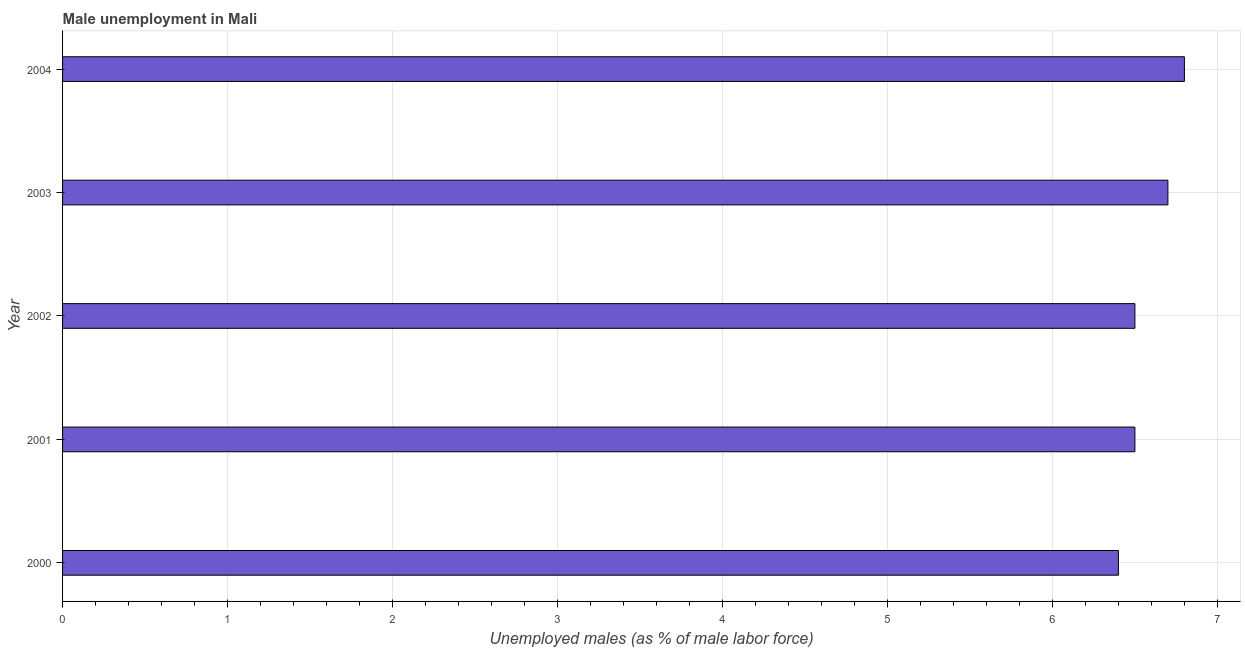Does the graph contain any zero values?
Ensure brevity in your answer.  No. What is the title of the graph?
Keep it short and to the point. Male unemployment in Mali. What is the label or title of the X-axis?
Offer a very short reply. Unemployed males (as % of male labor force). What is the unemployed males population in 2001?
Offer a terse response. 6.5. Across all years, what is the maximum unemployed males population?
Keep it short and to the point. 6.8. Across all years, what is the minimum unemployed males population?
Your answer should be very brief. 6.4. What is the sum of the unemployed males population?
Your response must be concise. 32.9. What is the difference between the unemployed males population in 2001 and 2003?
Offer a very short reply. -0.2. What is the average unemployed males population per year?
Offer a terse response. 6.58. What is the ratio of the unemployed males population in 2000 to that in 2004?
Give a very brief answer. 0.94. Is the unemployed males population in 2000 less than that in 2004?
Give a very brief answer. Yes. In how many years, is the unemployed males population greater than the average unemployed males population taken over all years?
Ensure brevity in your answer.  2. Are all the bars in the graph horizontal?
Offer a very short reply. Yes. What is the Unemployed males (as % of male labor force) in 2000?
Your answer should be compact. 6.4. What is the Unemployed males (as % of male labor force) in 2001?
Ensure brevity in your answer.  6.5. What is the Unemployed males (as % of male labor force) of 2002?
Make the answer very short. 6.5. What is the Unemployed males (as % of male labor force) of 2003?
Offer a terse response. 6.7. What is the Unemployed males (as % of male labor force) of 2004?
Provide a succinct answer. 6.8. What is the difference between the Unemployed males (as % of male labor force) in 2000 and 2001?
Your answer should be very brief. -0.1. What is the difference between the Unemployed males (as % of male labor force) in 2000 and 2003?
Keep it short and to the point. -0.3. What is the difference between the Unemployed males (as % of male labor force) in 2001 and 2003?
Offer a terse response. -0.2. What is the difference between the Unemployed males (as % of male labor force) in 2002 and 2004?
Keep it short and to the point. -0.3. What is the ratio of the Unemployed males (as % of male labor force) in 2000 to that in 2001?
Your response must be concise. 0.98. What is the ratio of the Unemployed males (as % of male labor force) in 2000 to that in 2003?
Provide a succinct answer. 0.95. What is the ratio of the Unemployed males (as % of male labor force) in 2000 to that in 2004?
Your answer should be compact. 0.94. What is the ratio of the Unemployed males (as % of male labor force) in 2001 to that in 2002?
Provide a succinct answer. 1. What is the ratio of the Unemployed males (as % of male labor force) in 2001 to that in 2003?
Provide a short and direct response. 0.97. What is the ratio of the Unemployed males (as % of male labor force) in 2001 to that in 2004?
Offer a very short reply. 0.96. What is the ratio of the Unemployed males (as % of male labor force) in 2002 to that in 2003?
Your answer should be very brief. 0.97. What is the ratio of the Unemployed males (as % of male labor force) in 2002 to that in 2004?
Ensure brevity in your answer.  0.96. 